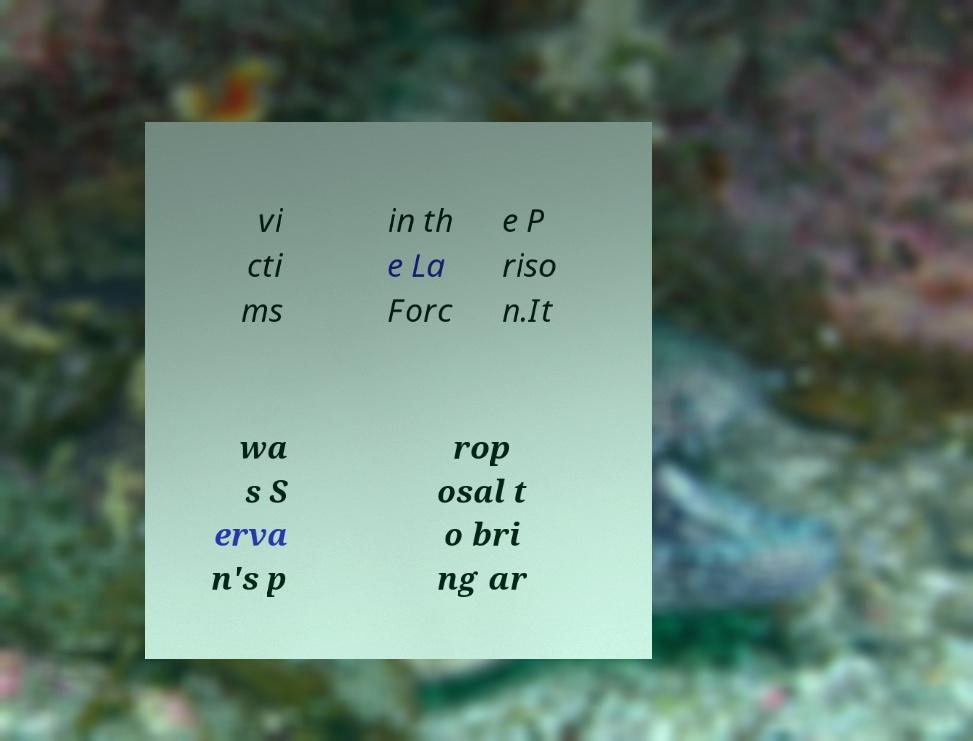Could you extract and type out the text from this image? vi cti ms in th e La Forc e P riso n.It wa s S erva n's p rop osal t o bri ng ar 